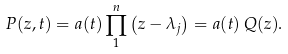<formula> <loc_0><loc_0><loc_500><loc_500>P ( z , t ) = a ( t ) \prod _ { 1 } ^ { n } \left ( z - \lambda _ { j } \right ) = a ( t ) \, Q ( z ) .</formula> 